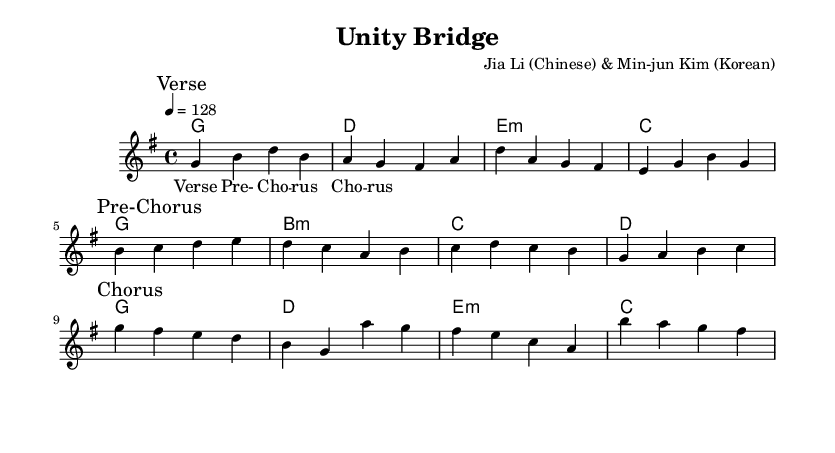What is the key signature of this music? The key signature shows one sharp, which indicates that the key is G major.
Answer: G major What is the time signature of this music? The time signature is indicated as 4/4, meaning there are four beats in each measure.
Answer: 4/4 What is the tempo marking for this piece? The tempo marking shows that the piece is to be played at 128 beats per minute.
Answer: 128 How many sections are indicated in the melody? The melody is divided into three sections: Verse, Pre-Chorus, and Chorus. Each section is marked in the music.
Answer: Three What chord is played in the first measure? The first measure has a G major chord indicated, which is represented in Roman numeral analysis as I.
Answer: G What is the lyric associated with the Pre-Chorus section? The lyrics for the Pre-Chorus section are marked directly above the melody and follow the pattern of syllables shown.
Answer: Pre-Chorus Which two composers collaborated on this piece? The header indicates that the piece was composed by Jia Li, a Chinese artist, and Min-jun Kim, a Korean artist.
Answer: Jia Li and Min-jun Kim 